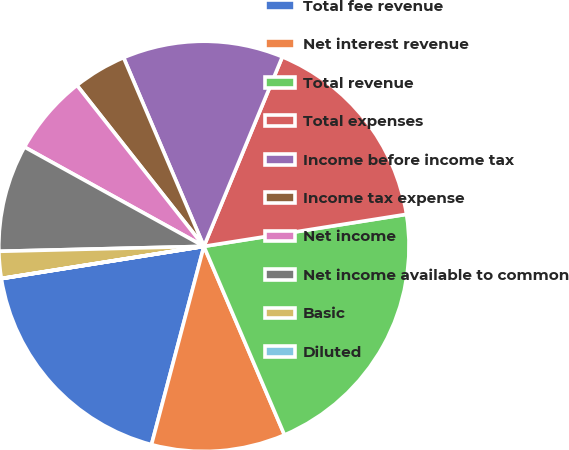<chart> <loc_0><loc_0><loc_500><loc_500><pie_chart><fcel>Total fee revenue<fcel>Net interest revenue<fcel>Total revenue<fcel>Total expenses<fcel>Income before income tax<fcel>Income tax expense<fcel>Net income<fcel>Net income available to common<fcel>Basic<fcel>Diluted<nl><fcel>18.37%<fcel>10.54%<fcel>21.07%<fcel>16.26%<fcel>12.65%<fcel>4.22%<fcel>6.33%<fcel>8.43%<fcel>2.12%<fcel>0.01%<nl></chart> 